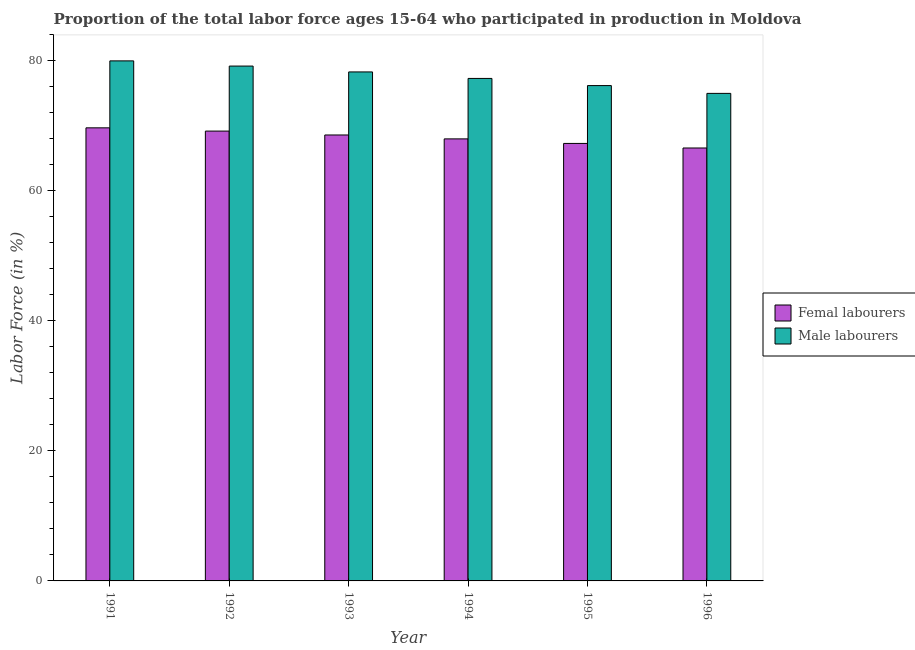How many groups of bars are there?
Provide a short and direct response. 6. Are the number of bars on each tick of the X-axis equal?
Provide a short and direct response. Yes. How many bars are there on the 3rd tick from the left?
Give a very brief answer. 2. Across all years, what is the minimum percentage of female labor force?
Make the answer very short. 66.6. In which year was the percentage of female labor force maximum?
Ensure brevity in your answer.  1991. What is the total percentage of male labour force in the graph?
Provide a succinct answer. 466. What is the difference between the percentage of female labor force in 1992 and that in 1996?
Offer a terse response. 2.6. What is the difference between the percentage of female labor force in 1994 and the percentage of male labour force in 1995?
Provide a succinct answer. 0.7. What is the average percentage of female labor force per year?
Provide a succinct answer. 68.23. In the year 1996, what is the difference between the percentage of female labor force and percentage of male labour force?
Keep it short and to the point. 0. In how many years, is the percentage of male labour force greater than 72 %?
Your response must be concise. 6. What is the ratio of the percentage of male labour force in 1991 to that in 1994?
Offer a terse response. 1.03. What is the difference between the highest and the second highest percentage of male labour force?
Ensure brevity in your answer.  0.8. What is the difference between the highest and the lowest percentage of male labour force?
Provide a succinct answer. 5. In how many years, is the percentage of female labor force greater than the average percentage of female labor force taken over all years?
Offer a terse response. 3. Is the sum of the percentage of female labor force in 1991 and 1995 greater than the maximum percentage of male labour force across all years?
Your response must be concise. Yes. What does the 1st bar from the left in 1994 represents?
Make the answer very short. Femal labourers. What does the 1st bar from the right in 1991 represents?
Make the answer very short. Male labourers. How many years are there in the graph?
Offer a terse response. 6. What is the difference between two consecutive major ticks on the Y-axis?
Provide a short and direct response. 20. Does the graph contain any zero values?
Provide a short and direct response. No. Does the graph contain grids?
Your response must be concise. No. Where does the legend appear in the graph?
Your response must be concise. Center right. How many legend labels are there?
Make the answer very short. 2. What is the title of the graph?
Give a very brief answer. Proportion of the total labor force ages 15-64 who participated in production in Moldova. Does "Import" appear as one of the legend labels in the graph?
Offer a very short reply. No. What is the label or title of the Y-axis?
Keep it short and to the point. Labor Force (in %). What is the Labor Force (in %) in Femal labourers in 1991?
Offer a very short reply. 69.7. What is the Labor Force (in %) of Male labourers in 1991?
Offer a very short reply. 80. What is the Labor Force (in %) in Femal labourers in 1992?
Offer a very short reply. 69.2. What is the Labor Force (in %) in Male labourers in 1992?
Provide a short and direct response. 79.2. What is the Labor Force (in %) of Femal labourers in 1993?
Your answer should be very brief. 68.6. What is the Labor Force (in %) of Male labourers in 1993?
Your response must be concise. 78.3. What is the Labor Force (in %) in Femal labourers in 1994?
Provide a succinct answer. 68. What is the Labor Force (in %) of Male labourers in 1994?
Keep it short and to the point. 77.3. What is the Labor Force (in %) of Femal labourers in 1995?
Make the answer very short. 67.3. What is the Labor Force (in %) of Male labourers in 1995?
Give a very brief answer. 76.2. What is the Labor Force (in %) of Femal labourers in 1996?
Your response must be concise. 66.6. What is the Labor Force (in %) in Male labourers in 1996?
Your answer should be compact. 75. Across all years, what is the maximum Labor Force (in %) of Femal labourers?
Keep it short and to the point. 69.7. Across all years, what is the minimum Labor Force (in %) of Femal labourers?
Provide a short and direct response. 66.6. What is the total Labor Force (in %) in Femal labourers in the graph?
Offer a very short reply. 409.4. What is the total Labor Force (in %) of Male labourers in the graph?
Give a very brief answer. 466. What is the difference between the Labor Force (in %) in Femal labourers in 1991 and that in 1993?
Offer a very short reply. 1.1. What is the difference between the Labor Force (in %) in Male labourers in 1991 and that in 1993?
Offer a very short reply. 1.7. What is the difference between the Labor Force (in %) in Male labourers in 1991 and that in 1994?
Your answer should be very brief. 2.7. What is the difference between the Labor Force (in %) in Male labourers in 1991 and that in 1995?
Keep it short and to the point. 3.8. What is the difference between the Labor Force (in %) in Femal labourers in 1992 and that in 1993?
Make the answer very short. 0.6. What is the difference between the Labor Force (in %) in Femal labourers in 1992 and that in 1994?
Your answer should be compact. 1.2. What is the difference between the Labor Force (in %) in Femal labourers in 1992 and that in 1996?
Offer a terse response. 2.6. What is the difference between the Labor Force (in %) in Male labourers in 1992 and that in 1996?
Offer a very short reply. 4.2. What is the difference between the Labor Force (in %) of Femal labourers in 1993 and that in 1994?
Keep it short and to the point. 0.6. What is the difference between the Labor Force (in %) of Male labourers in 1993 and that in 1995?
Keep it short and to the point. 2.1. What is the difference between the Labor Force (in %) in Femal labourers in 1993 and that in 1996?
Ensure brevity in your answer.  2. What is the difference between the Labor Force (in %) in Male labourers in 1994 and that in 1995?
Keep it short and to the point. 1.1. What is the difference between the Labor Force (in %) of Femal labourers in 1991 and the Labor Force (in %) of Male labourers in 1994?
Offer a very short reply. -7.6. What is the difference between the Labor Force (in %) of Femal labourers in 1991 and the Labor Force (in %) of Male labourers in 1995?
Ensure brevity in your answer.  -6.5. What is the difference between the Labor Force (in %) in Femal labourers in 1991 and the Labor Force (in %) in Male labourers in 1996?
Your response must be concise. -5.3. What is the difference between the Labor Force (in %) of Femal labourers in 1992 and the Labor Force (in %) of Male labourers in 1993?
Offer a terse response. -9.1. What is the difference between the Labor Force (in %) of Femal labourers in 1992 and the Labor Force (in %) of Male labourers in 1994?
Give a very brief answer. -8.1. What is the difference between the Labor Force (in %) of Femal labourers in 1992 and the Labor Force (in %) of Male labourers in 1995?
Your answer should be compact. -7. What is the difference between the Labor Force (in %) of Femal labourers in 1992 and the Labor Force (in %) of Male labourers in 1996?
Make the answer very short. -5.8. What is the difference between the Labor Force (in %) in Femal labourers in 1994 and the Labor Force (in %) in Male labourers in 1996?
Your answer should be compact. -7. What is the difference between the Labor Force (in %) in Femal labourers in 1995 and the Labor Force (in %) in Male labourers in 1996?
Your response must be concise. -7.7. What is the average Labor Force (in %) of Femal labourers per year?
Make the answer very short. 68.23. What is the average Labor Force (in %) in Male labourers per year?
Your response must be concise. 77.67. In the year 1992, what is the difference between the Labor Force (in %) in Femal labourers and Labor Force (in %) in Male labourers?
Offer a very short reply. -10. In the year 1993, what is the difference between the Labor Force (in %) of Femal labourers and Labor Force (in %) of Male labourers?
Provide a succinct answer. -9.7. In the year 1995, what is the difference between the Labor Force (in %) in Femal labourers and Labor Force (in %) in Male labourers?
Your answer should be very brief. -8.9. What is the ratio of the Labor Force (in %) of Male labourers in 1991 to that in 1992?
Offer a very short reply. 1.01. What is the ratio of the Labor Force (in %) of Femal labourers in 1991 to that in 1993?
Your response must be concise. 1.02. What is the ratio of the Labor Force (in %) of Male labourers in 1991 to that in 1993?
Provide a succinct answer. 1.02. What is the ratio of the Labor Force (in %) in Femal labourers in 1991 to that in 1994?
Your response must be concise. 1.02. What is the ratio of the Labor Force (in %) of Male labourers in 1991 to that in 1994?
Give a very brief answer. 1.03. What is the ratio of the Labor Force (in %) in Femal labourers in 1991 to that in 1995?
Offer a terse response. 1.04. What is the ratio of the Labor Force (in %) in Male labourers in 1991 to that in 1995?
Provide a succinct answer. 1.05. What is the ratio of the Labor Force (in %) in Femal labourers in 1991 to that in 1996?
Offer a very short reply. 1.05. What is the ratio of the Labor Force (in %) in Male labourers in 1991 to that in 1996?
Your response must be concise. 1.07. What is the ratio of the Labor Force (in %) of Femal labourers in 1992 to that in 1993?
Your response must be concise. 1.01. What is the ratio of the Labor Force (in %) in Male labourers in 1992 to that in 1993?
Provide a succinct answer. 1.01. What is the ratio of the Labor Force (in %) in Femal labourers in 1992 to that in 1994?
Keep it short and to the point. 1.02. What is the ratio of the Labor Force (in %) of Male labourers in 1992 to that in 1994?
Your response must be concise. 1.02. What is the ratio of the Labor Force (in %) of Femal labourers in 1992 to that in 1995?
Give a very brief answer. 1.03. What is the ratio of the Labor Force (in %) of Male labourers in 1992 to that in 1995?
Offer a terse response. 1.04. What is the ratio of the Labor Force (in %) in Femal labourers in 1992 to that in 1996?
Your response must be concise. 1.04. What is the ratio of the Labor Force (in %) of Male labourers in 1992 to that in 1996?
Offer a terse response. 1.06. What is the ratio of the Labor Force (in %) of Femal labourers in 1993 to that in 1994?
Provide a succinct answer. 1.01. What is the ratio of the Labor Force (in %) in Male labourers in 1993 to that in 1994?
Your answer should be compact. 1.01. What is the ratio of the Labor Force (in %) in Femal labourers in 1993 to that in 1995?
Keep it short and to the point. 1.02. What is the ratio of the Labor Force (in %) in Male labourers in 1993 to that in 1995?
Your response must be concise. 1.03. What is the ratio of the Labor Force (in %) in Femal labourers in 1993 to that in 1996?
Make the answer very short. 1.03. What is the ratio of the Labor Force (in %) in Male labourers in 1993 to that in 1996?
Offer a very short reply. 1.04. What is the ratio of the Labor Force (in %) in Femal labourers in 1994 to that in 1995?
Ensure brevity in your answer.  1.01. What is the ratio of the Labor Force (in %) of Male labourers in 1994 to that in 1995?
Ensure brevity in your answer.  1.01. What is the ratio of the Labor Force (in %) of Male labourers in 1994 to that in 1996?
Provide a short and direct response. 1.03. What is the ratio of the Labor Force (in %) of Femal labourers in 1995 to that in 1996?
Provide a short and direct response. 1.01. What is the ratio of the Labor Force (in %) of Male labourers in 1995 to that in 1996?
Give a very brief answer. 1.02. What is the difference between the highest and the second highest Labor Force (in %) in Femal labourers?
Keep it short and to the point. 0.5. What is the difference between the highest and the lowest Labor Force (in %) of Femal labourers?
Offer a very short reply. 3.1. 